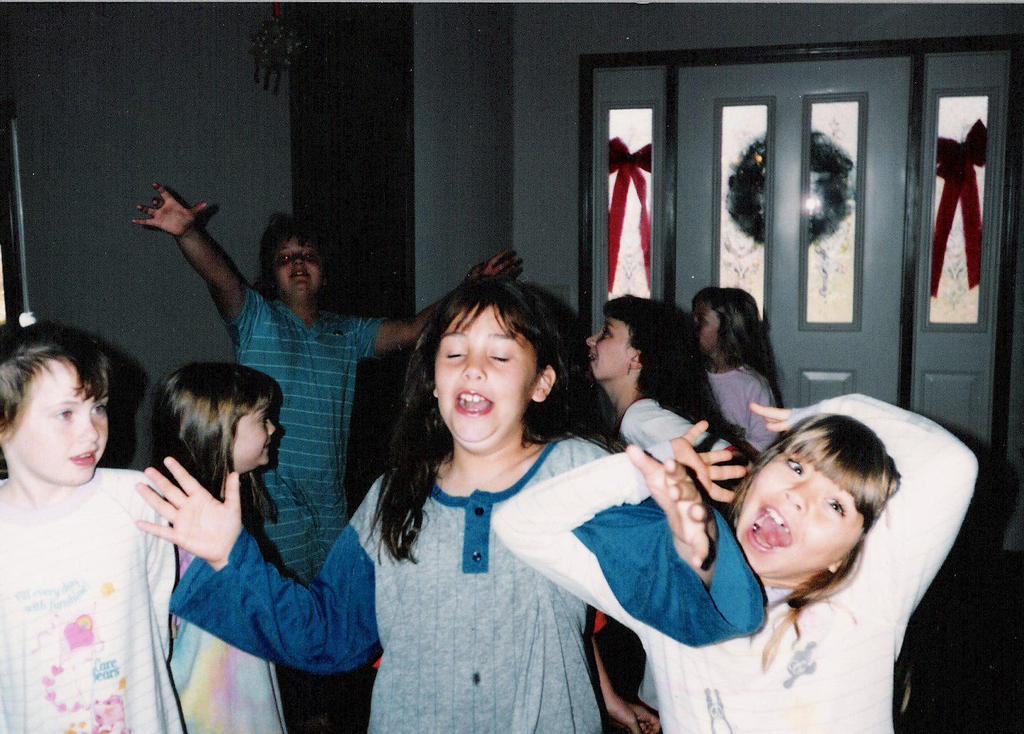Can you describe this image briefly? In this image there are a few kids playing, behind them there is a glass door. 